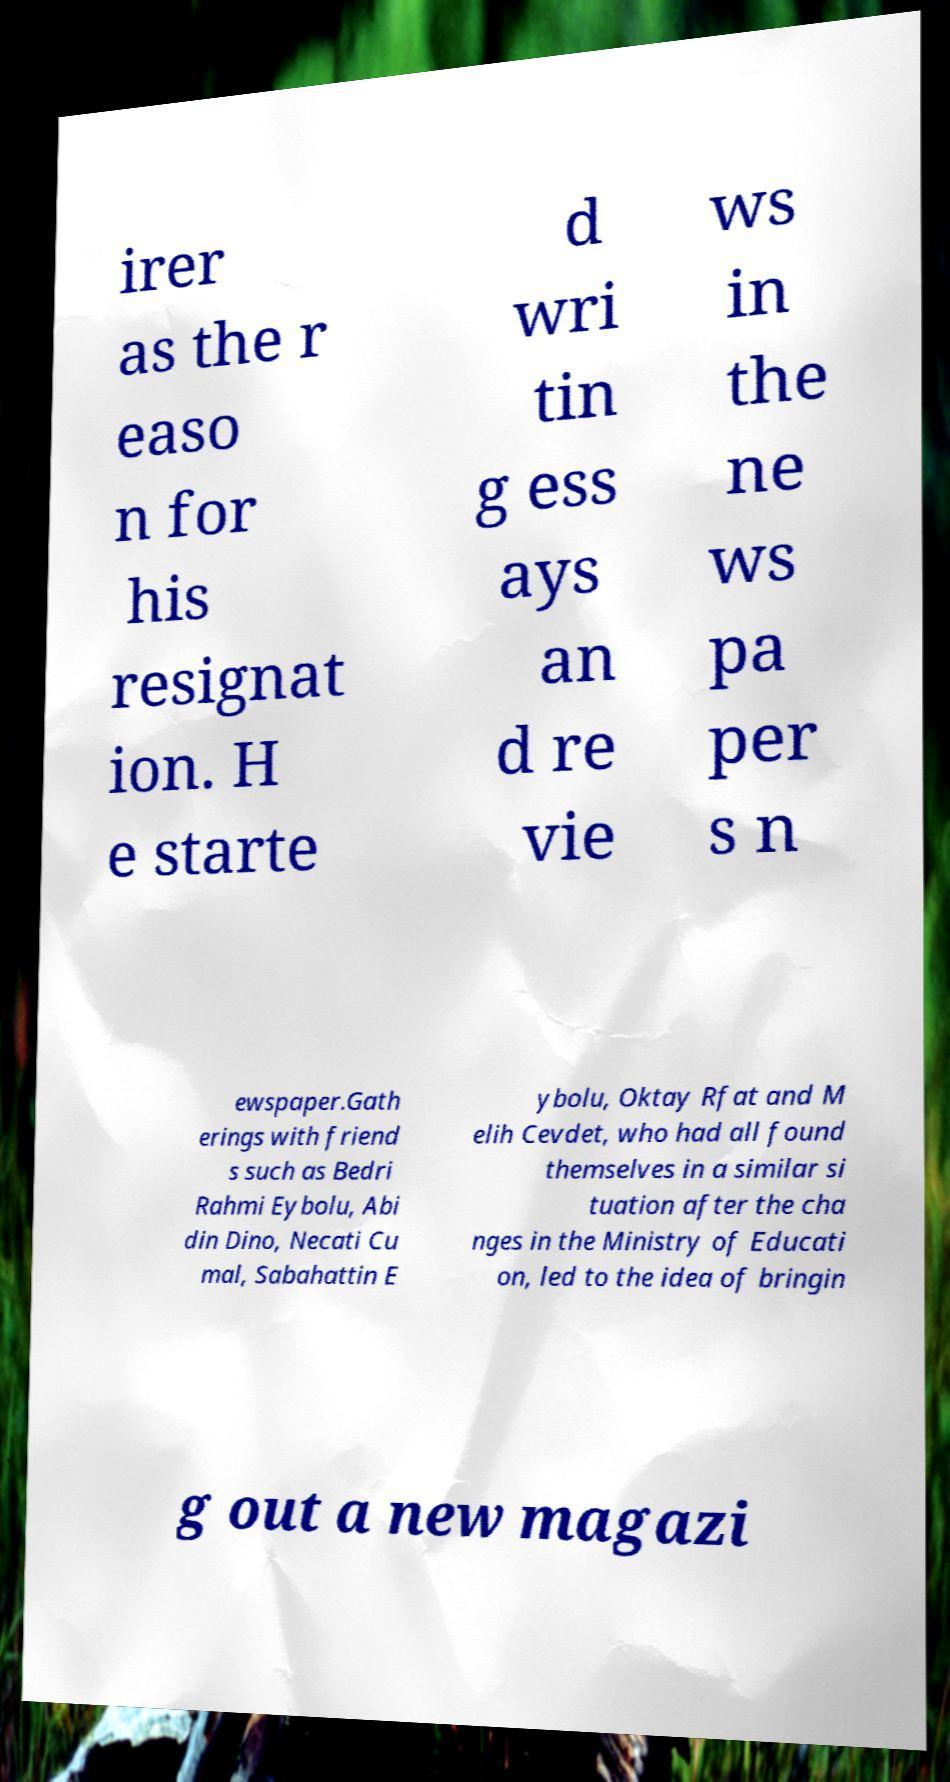Please identify and transcribe the text found in this image. irer as the r easo n for his resignat ion. H e starte d wri tin g ess ays an d re vie ws in the ne ws pa per s n ewspaper.Gath erings with friend s such as Bedri Rahmi Eybolu, Abi din Dino, Necati Cu mal, Sabahattin E ybolu, Oktay Rfat and M elih Cevdet, who had all found themselves in a similar si tuation after the cha nges in the Ministry of Educati on, led to the idea of bringin g out a new magazi 